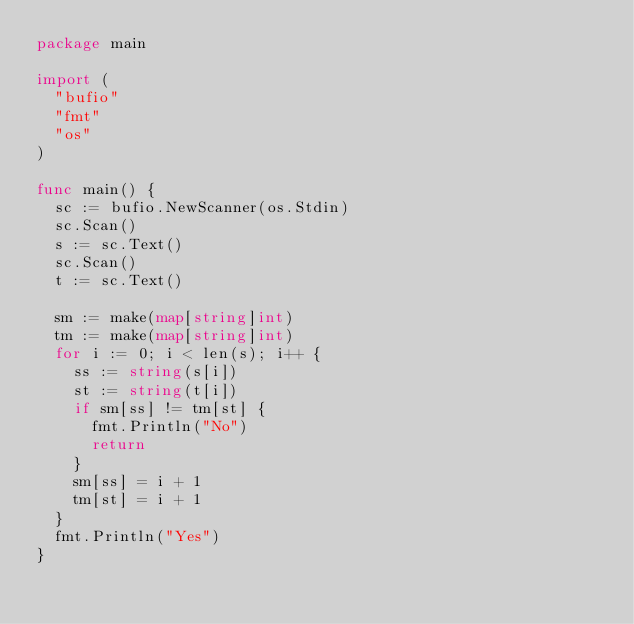<code> <loc_0><loc_0><loc_500><loc_500><_Go_>package main

import (
	"bufio"
	"fmt"
	"os"
)

func main() {
	sc := bufio.NewScanner(os.Stdin)
	sc.Scan()
	s := sc.Text()
	sc.Scan()
	t := sc.Text()

	sm := make(map[string]int)
	tm := make(map[string]int)
	for i := 0; i < len(s); i++ {
		ss := string(s[i])
		st := string(t[i])
		if sm[ss] != tm[st] {
			fmt.Println("No")
			return
		}
		sm[ss] = i + 1
		tm[st] = i + 1
	}
	fmt.Println("Yes")
}
</code> 